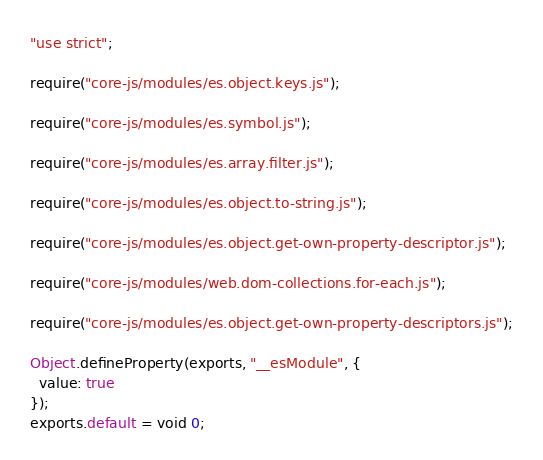<code> <loc_0><loc_0><loc_500><loc_500><_JavaScript_>"use strict";

require("core-js/modules/es.object.keys.js");

require("core-js/modules/es.symbol.js");

require("core-js/modules/es.array.filter.js");

require("core-js/modules/es.object.to-string.js");

require("core-js/modules/es.object.get-own-property-descriptor.js");

require("core-js/modules/web.dom-collections.for-each.js");

require("core-js/modules/es.object.get-own-property-descriptors.js");

Object.defineProperty(exports, "__esModule", {
  value: true
});
exports.default = void 0;
</code> 